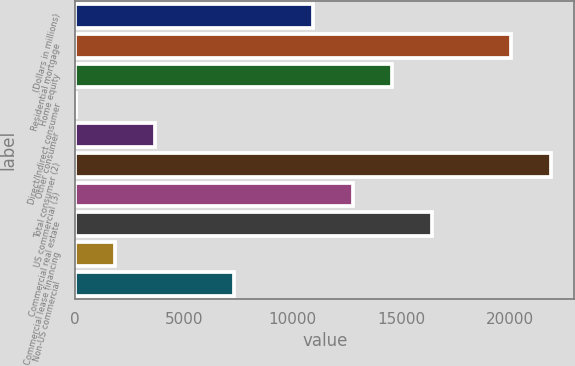<chart> <loc_0><loc_0><loc_500><loc_500><bar_chart><fcel>(Dollars in millions)<fcel>Residential mortgage<fcel>Home equity<fcel>Direct/Indirect consumer<fcel>Other consumer<fcel>Total consumer (2)<fcel>US commercial (3)<fcel>Commercial real estate<fcel>Commercial lease financing<fcel>Non-US commercial<nl><fcel>10937.6<fcel>20030.6<fcel>14574.8<fcel>26<fcel>3663.2<fcel>21849.2<fcel>12756.2<fcel>16393.4<fcel>1844.6<fcel>7300.4<nl></chart> 